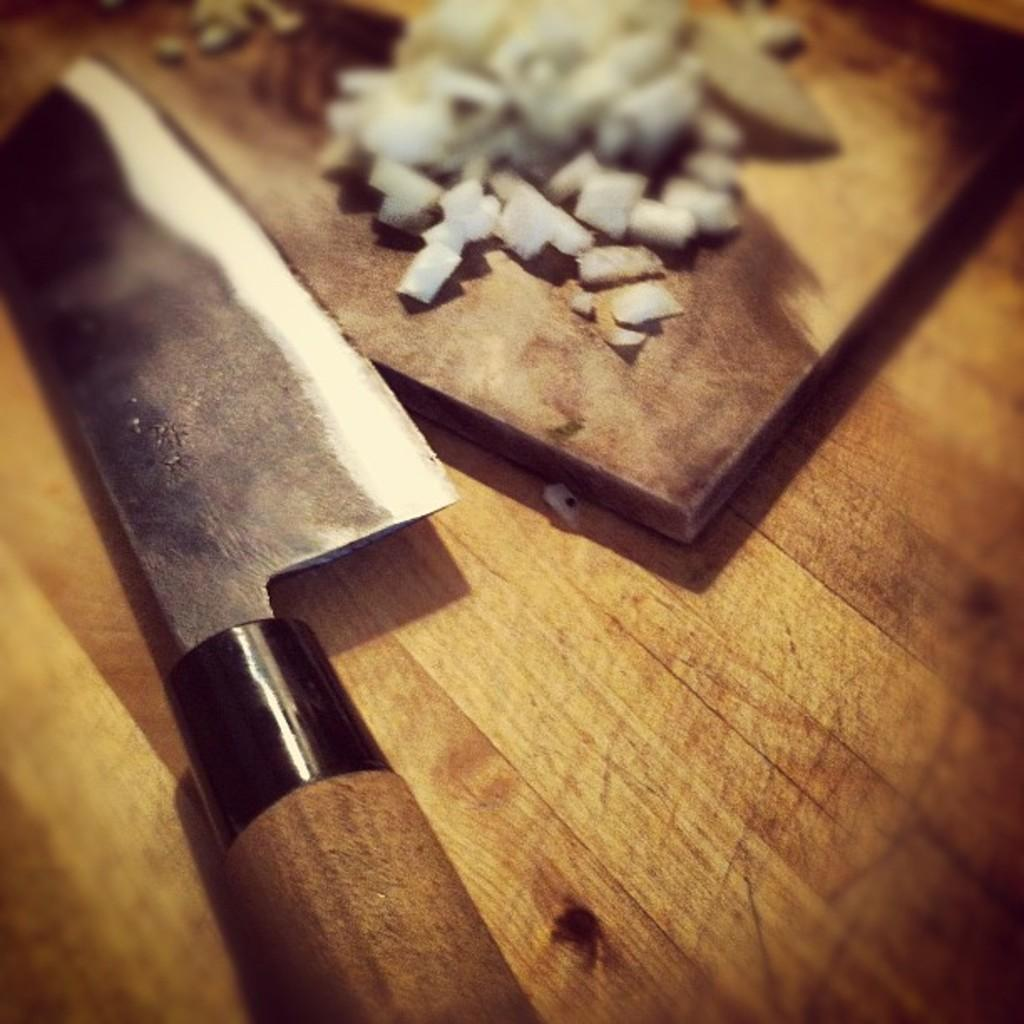What object is present in the image that is typically used for cutting? There is a knife in the image. What type of food is visible in the image? There are vegetable pieces in the image. On what surface are the vegetable pieces placed? The vegetable pieces are on a wooden plate. What is the wooden plate placed on in the image? The wooden plate is on a wooden table. What type of grain is being harvested in the image? There is no grain or harvesting activity present in the image. What type of skirt is the person wearing in the image? There is no person or skirt present in the image. 